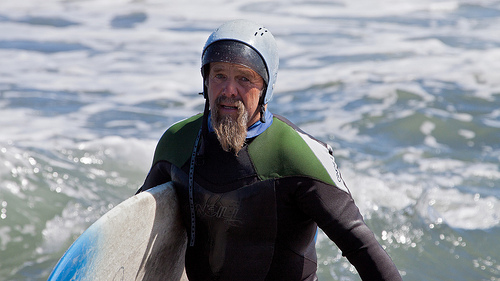What kind of conditions does the water seem to suggest for surfing today? The water appears choppy with moderate waves, indicating reasonably good conditions for experienced surfers seeking a challenge, but potentially difficult for beginners. 